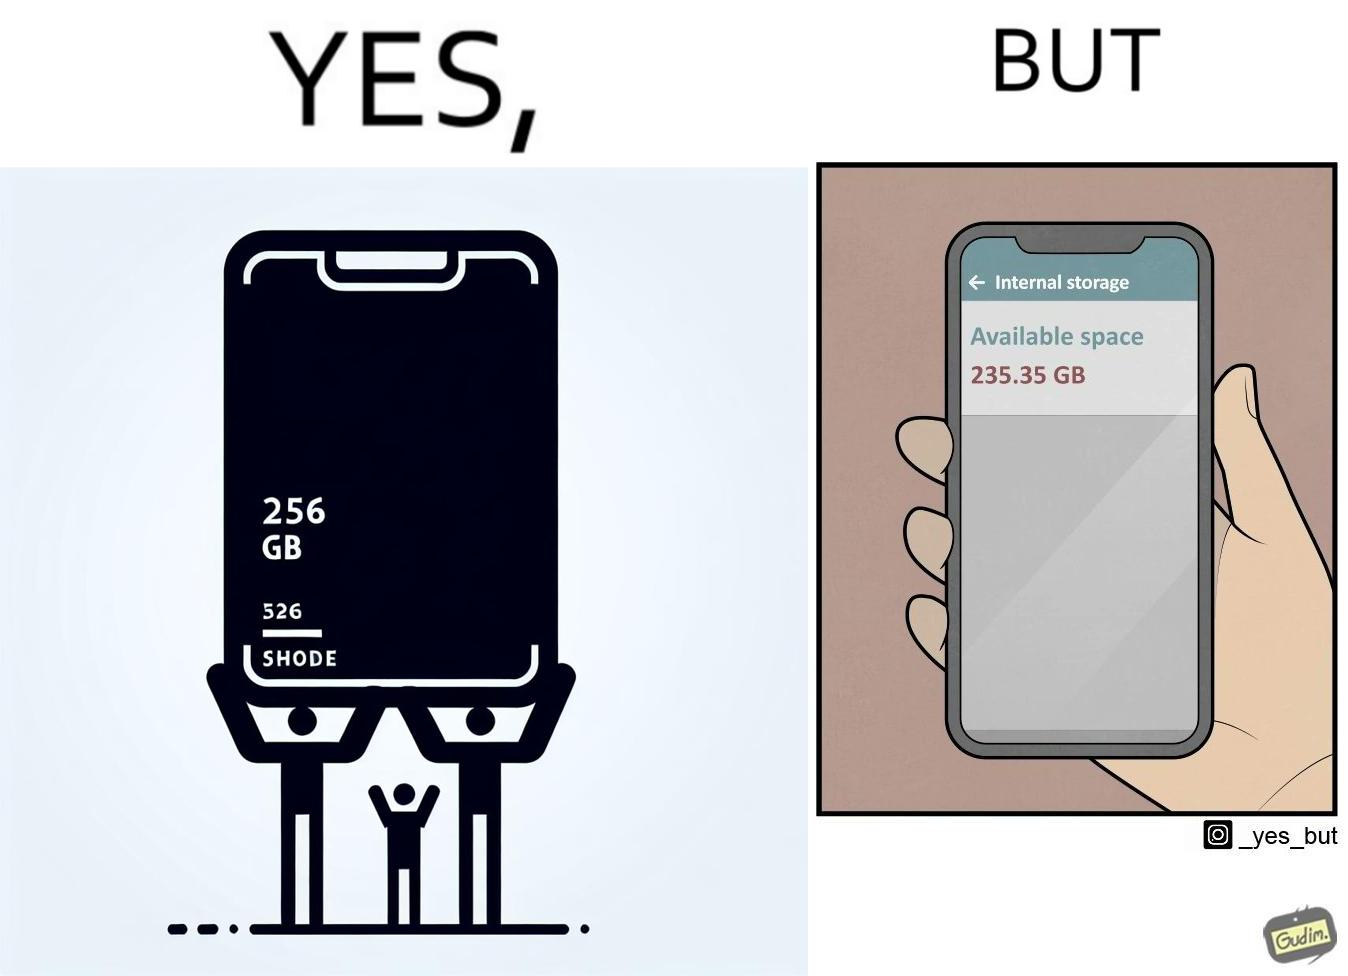Is this a satirical image? Yes, this image is satirical. 